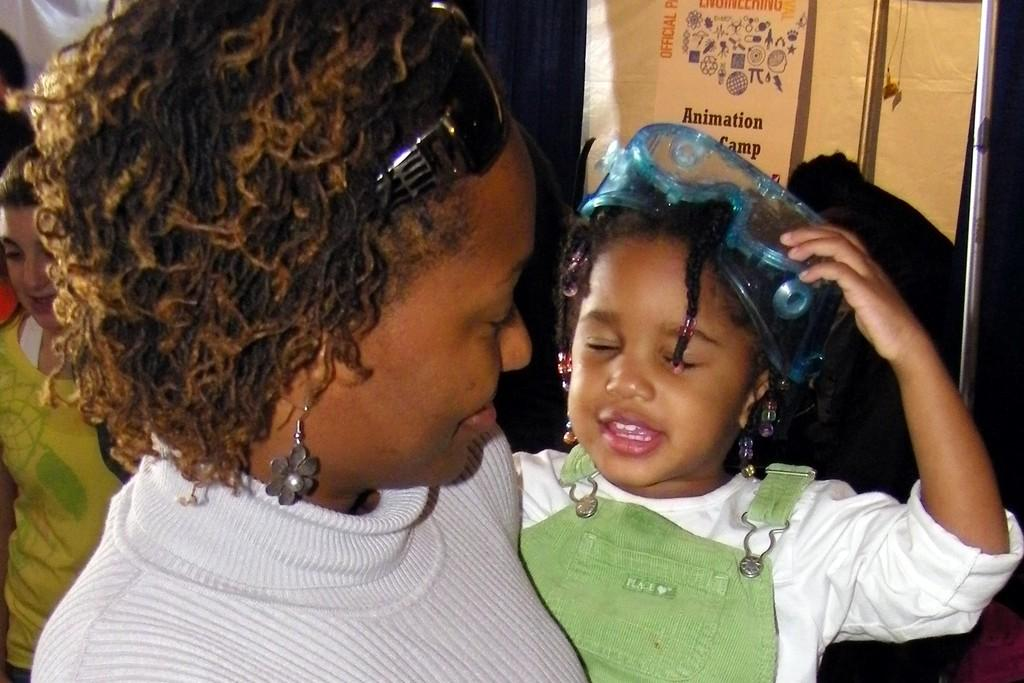How many people are in the image? There is a group of people in the image. What colors are the dresses of some of the people in the image? Some of the people are wearing white, green, and yellow color dresses. Can you describe any accessories worn by the people in the image? One person is wearing goggles. What can be seen in the background of the image? There is a banner visible in the background of the image. How many fingers are visible on the person wearing goggles in the image? The image does not provide enough detail to count the fingers of the person wearing goggles. 